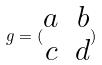<formula> <loc_0><loc_0><loc_500><loc_500>g = ( \begin{matrix} a & b \\ c & d \end{matrix} )</formula> 